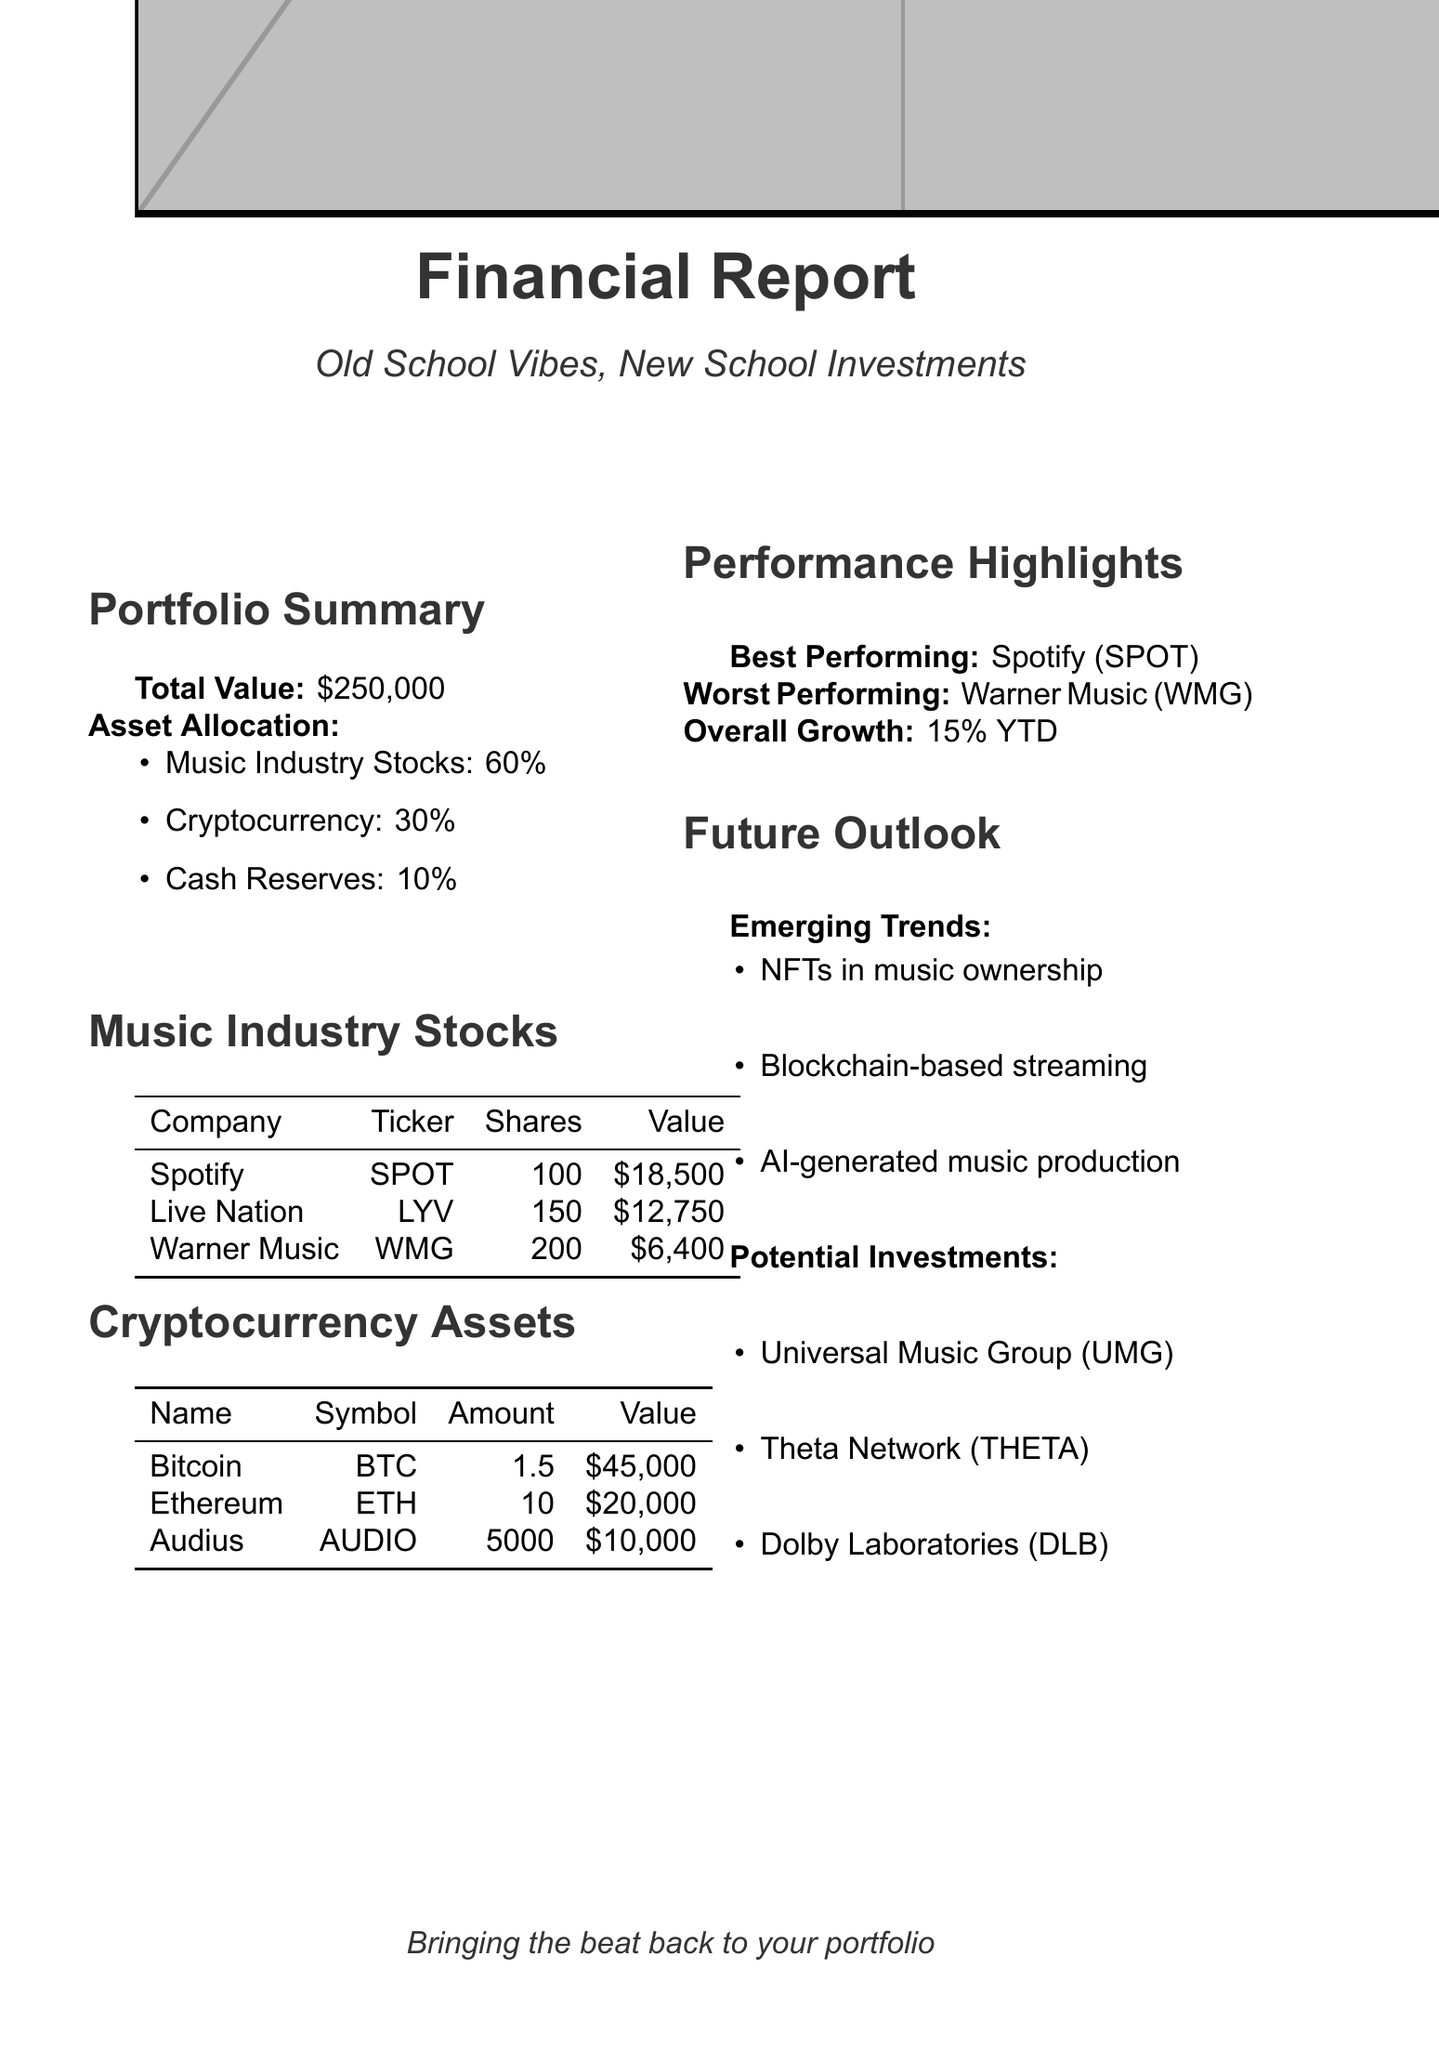What is the total value of the portfolio? The total value of the portfolio is explicitly stated in the document.
Answer: $250,000 What percentage of the portfolio is allocated to cash reserves? The document provides the percentage for cash reserves as part of the asset allocation.
Answer: 10% Which company is the best performing asset? The best performing asset is highlighted in the performance section of the document.
Answer: Spotify Technology S.A. (SPOT) How many shares of Live Nation does the portfolio hold? The number of shares of Live Nation is detailed in the music industry stocks section.
Answer: 150 What is the current value of Bitcoin in the portfolio? The current value of Bitcoin is listed in the cryptocurrency assets section.
Answer: $45,000 Which company has the worst performance? The worst performing asset is indicated in the performance highlights of the document.
Answer: Warner Music Group Corp. (WMG) What is the overall portfolio growth year-to-date? The document states the overall growth percentage in the performance highlights.
Answer: 15% YTD What emerging trend in the music industry is mentioned? One of the emerging trends in the future outlook section is specified.
Answer: NFTs in music ownership and distribution What is one potential investment suggested in the document? The document lists potential investments in the future outlook section.
Answer: Universal Music Group (UMG) 